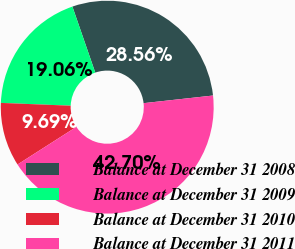Convert chart to OTSL. <chart><loc_0><loc_0><loc_500><loc_500><pie_chart><fcel>Balance at December 31 2008<fcel>Balance at December 31 2009<fcel>Balance at December 31 2010<fcel>Balance at December 31 2011<nl><fcel>28.56%<fcel>19.06%<fcel>9.69%<fcel>42.7%<nl></chart> 